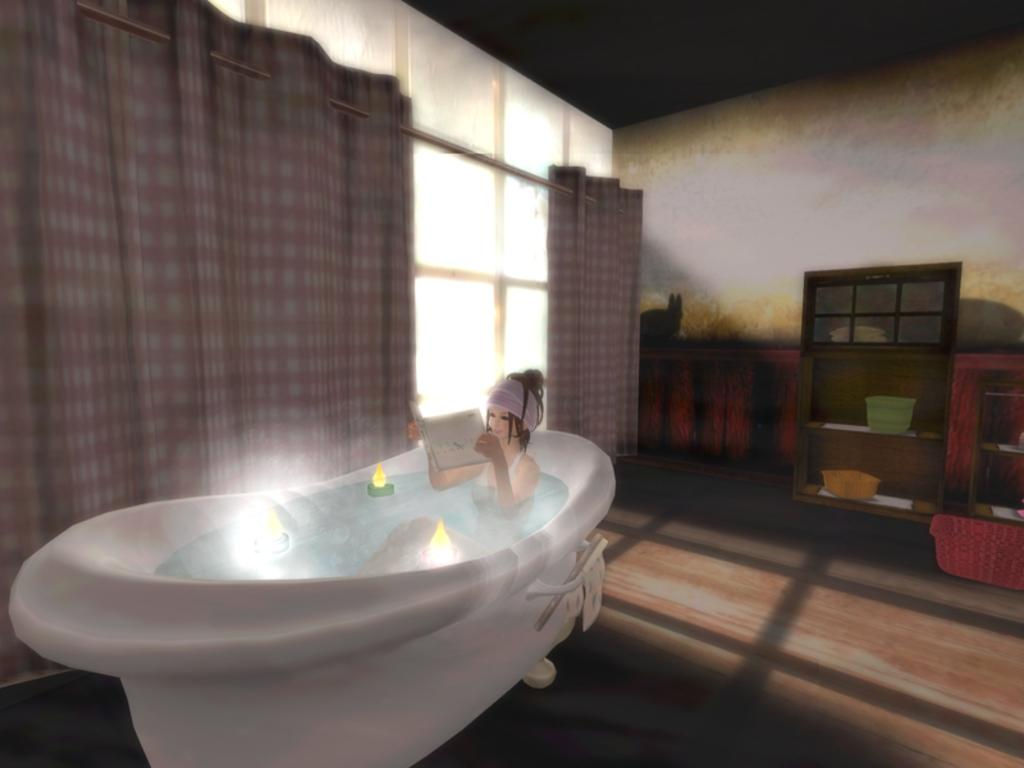Who is present in the image? There is a woman in the image. What is the woman holding in the image? The woman is holding a book. Where is the woman sitting in the image? The woman is sitting on a bathtub. What can be seen on the wall in the image? There are curtains and windows on the wall in the image. What type of furniture is present in the image? There are shelves and trays in the image. What is the main feature of the room in the image? There is a tub in the image. What type of vase is sitting on the skirt of the woman in the image? There is no vase or skirt present in the image; the woman is sitting on a bathtub and holding a book. 